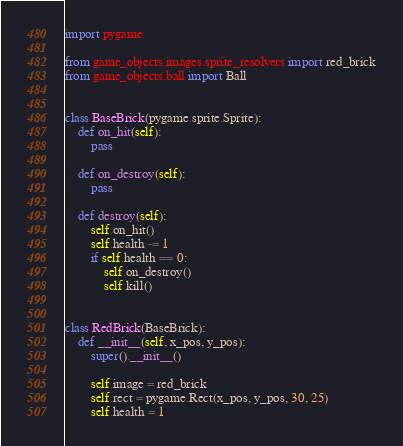<code> <loc_0><loc_0><loc_500><loc_500><_Python_>import pygame

from game_objects.images.sprite_resolvers import red_brick
from game_objects.ball import Ball


class BaseBrick(pygame.sprite.Sprite):
    def on_hit(self):
        pass

    def on_destroy(self):
        pass

    def destroy(self):
        self.on_hit()
        self.health -= 1
        if self.health == 0:
            self.on_destroy()
            self.kill()


class RedBrick(BaseBrick):
    def __init__(self, x_pos, y_pos):
        super().__init__()

        self.image = red_brick
        self.rect = pygame.Rect(x_pos, y_pos, 30, 25)
        self.health = 1
</code> 